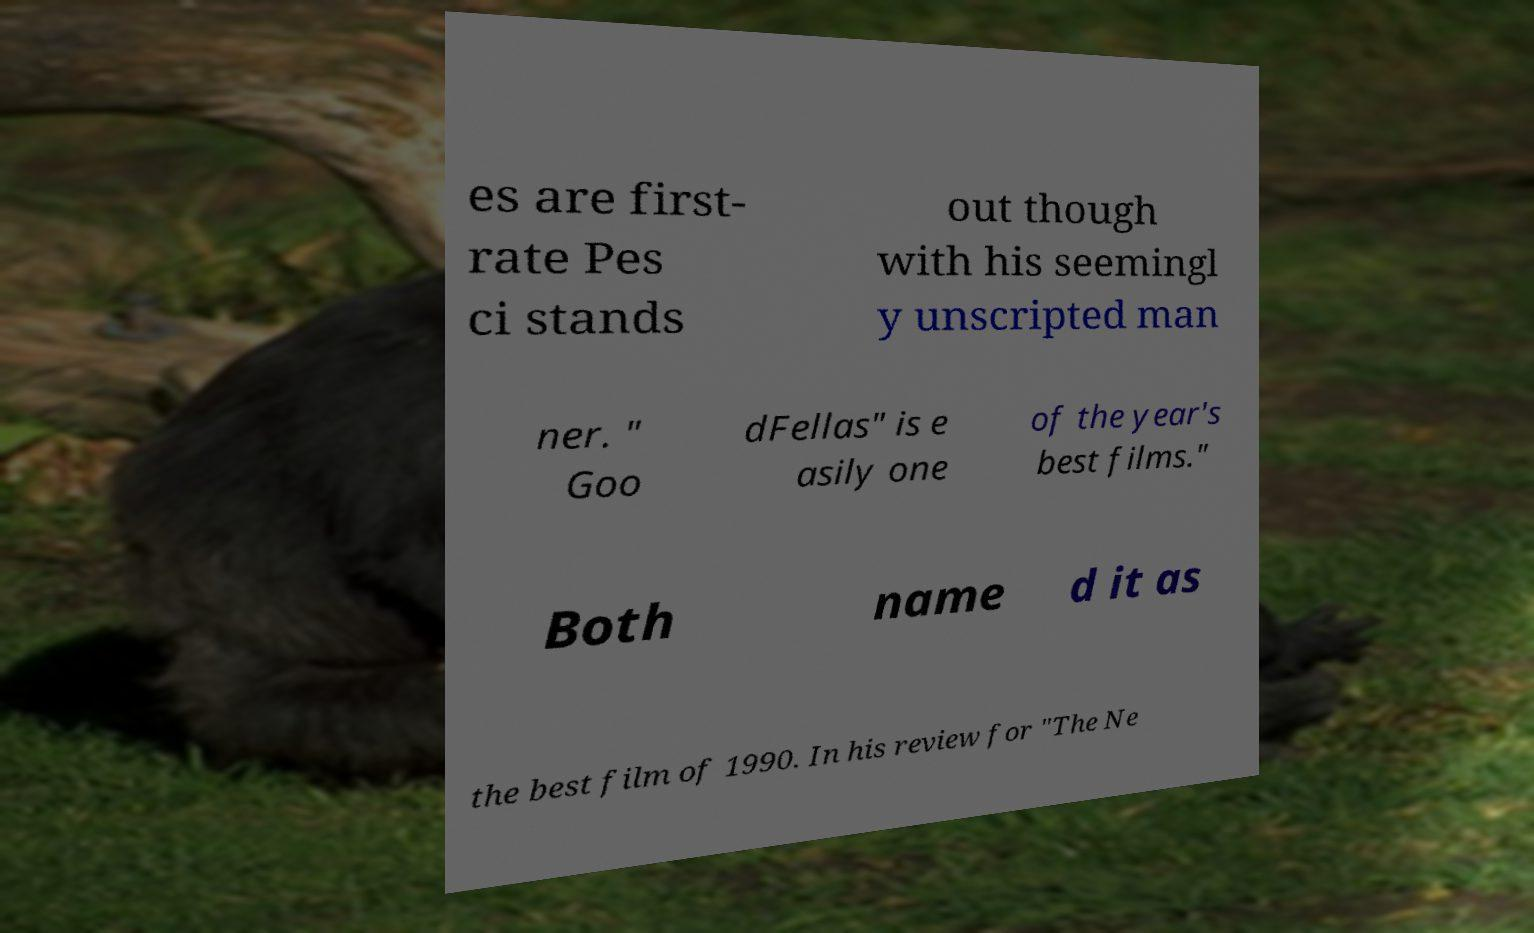Can you accurately transcribe the text from the provided image for me? es are first- rate Pes ci stands out though with his seemingl y unscripted man ner. " Goo dFellas" is e asily one of the year's best films." Both name d it as the best film of 1990. In his review for "The Ne 